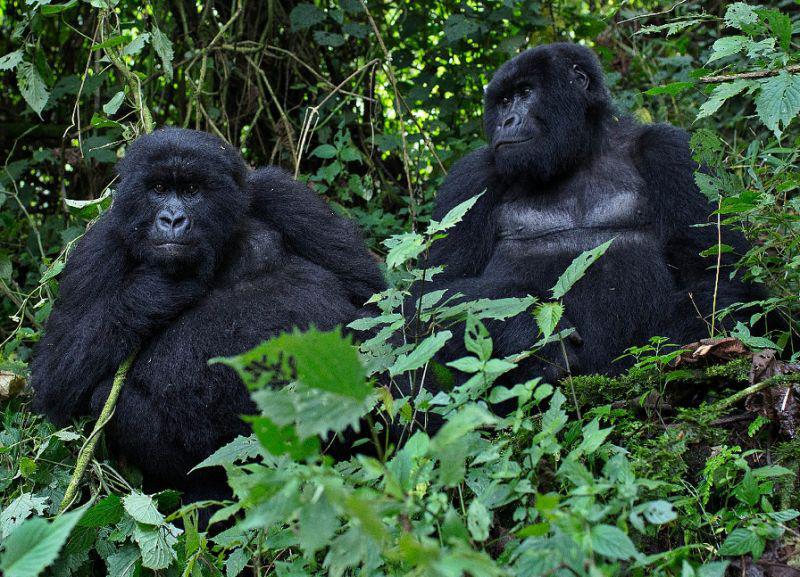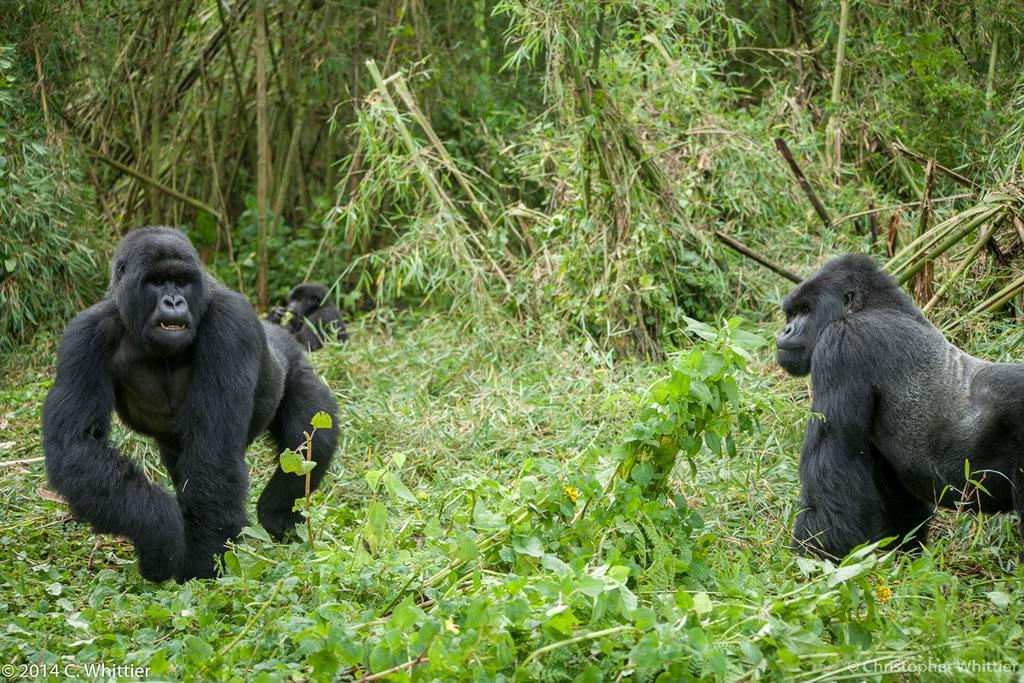The first image is the image on the left, the second image is the image on the right. For the images shown, is this caption "An image containing exactly two gorillas includes a male gorilla on all fours moving toward the camera." true? Answer yes or no. Yes. 